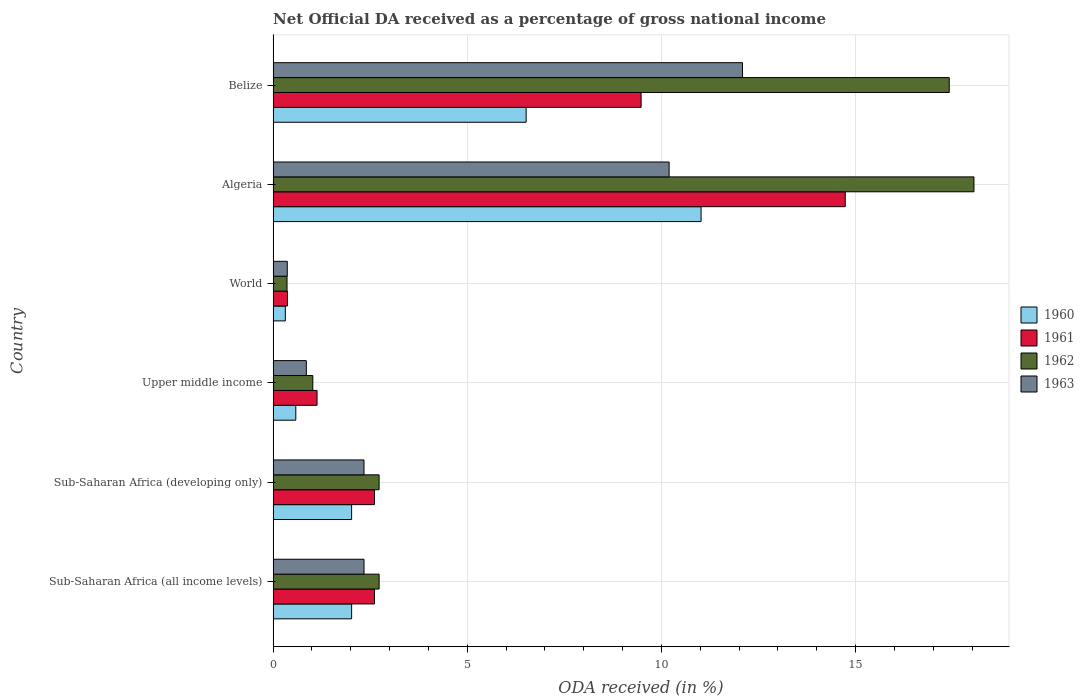How many groups of bars are there?
Keep it short and to the point. 6. Are the number of bars per tick equal to the number of legend labels?
Make the answer very short. Yes. Are the number of bars on each tick of the Y-axis equal?
Provide a short and direct response. Yes. How many bars are there on the 3rd tick from the top?
Your answer should be very brief. 4. How many bars are there on the 3rd tick from the bottom?
Offer a very short reply. 4. What is the label of the 6th group of bars from the top?
Offer a terse response. Sub-Saharan Africa (all income levels). In how many cases, is the number of bars for a given country not equal to the number of legend labels?
Give a very brief answer. 0. What is the net official DA received in 1962 in Sub-Saharan Africa (developing only)?
Offer a terse response. 2.73. Across all countries, what is the maximum net official DA received in 1961?
Offer a terse response. 14.73. Across all countries, what is the minimum net official DA received in 1961?
Give a very brief answer. 0.37. In which country was the net official DA received in 1962 maximum?
Ensure brevity in your answer.  Algeria. In which country was the net official DA received in 1963 minimum?
Your response must be concise. World. What is the total net official DA received in 1961 in the graph?
Provide a short and direct response. 30.93. What is the difference between the net official DA received in 1962 in Sub-Saharan Africa (all income levels) and that in World?
Offer a very short reply. 2.37. What is the difference between the net official DA received in 1962 in World and the net official DA received in 1960 in Belize?
Your answer should be compact. -6.16. What is the average net official DA received in 1963 per country?
Offer a terse response. 4.7. What is the difference between the net official DA received in 1963 and net official DA received in 1960 in World?
Your response must be concise. 0.05. What is the ratio of the net official DA received in 1961 in Belize to that in Sub-Saharan Africa (developing only)?
Your answer should be very brief. 3.63. What is the difference between the highest and the second highest net official DA received in 1963?
Your response must be concise. 1.89. What is the difference between the highest and the lowest net official DA received in 1960?
Ensure brevity in your answer.  10.71. In how many countries, is the net official DA received in 1961 greater than the average net official DA received in 1961 taken over all countries?
Provide a short and direct response. 2. What does the 2nd bar from the bottom in World represents?
Offer a terse response. 1961. Are all the bars in the graph horizontal?
Your response must be concise. Yes. How many countries are there in the graph?
Provide a short and direct response. 6. Are the values on the major ticks of X-axis written in scientific E-notation?
Give a very brief answer. No. Does the graph contain any zero values?
Ensure brevity in your answer.  No. Does the graph contain grids?
Offer a terse response. Yes. Where does the legend appear in the graph?
Your answer should be very brief. Center right. How many legend labels are there?
Your answer should be compact. 4. How are the legend labels stacked?
Your answer should be compact. Vertical. What is the title of the graph?
Keep it short and to the point. Net Official DA received as a percentage of gross national income. Does "1978" appear as one of the legend labels in the graph?
Your answer should be compact. No. What is the label or title of the X-axis?
Your answer should be compact. ODA received (in %). What is the ODA received (in %) of 1960 in Sub-Saharan Africa (all income levels)?
Your answer should be very brief. 2.02. What is the ODA received (in %) in 1961 in Sub-Saharan Africa (all income levels)?
Provide a succinct answer. 2.61. What is the ODA received (in %) in 1962 in Sub-Saharan Africa (all income levels)?
Give a very brief answer. 2.73. What is the ODA received (in %) of 1963 in Sub-Saharan Africa (all income levels)?
Offer a terse response. 2.34. What is the ODA received (in %) in 1960 in Sub-Saharan Africa (developing only)?
Provide a succinct answer. 2.02. What is the ODA received (in %) in 1961 in Sub-Saharan Africa (developing only)?
Offer a terse response. 2.61. What is the ODA received (in %) in 1962 in Sub-Saharan Africa (developing only)?
Give a very brief answer. 2.73. What is the ODA received (in %) in 1963 in Sub-Saharan Africa (developing only)?
Make the answer very short. 2.34. What is the ODA received (in %) in 1960 in Upper middle income?
Offer a terse response. 0.58. What is the ODA received (in %) of 1961 in Upper middle income?
Offer a very short reply. 1.13. What is the ODA received (in %) in 1962 in Upper middle income?
Keep it short and to the point. 1.02. What is the ODA received (in %) of 1963 in Upper middle income?
Offer a very short reply. 0.86. What is the ODA received (in %) in 1960 in World?
Provide a succinct answer. 0.31. What is the ODA received (in %) of 1961 in World?
Offer a very short reply. 0.37. What is the ODA received (in %) in 1962 in World?
Your answer should be compact. 0.36. What is the ODA received (in %) of 1963 in World?
Provide a short and direct response. 0.36. What is the ODA received (in %) in 1960 in Algeria?
Keep it short and to the point. 11.02. What is the ODA received (in %) of 1961 in Algeria?
Offer a terse response. 14.73. What is the ODA received (in %) in 1962 in Algeria?
Make the answer very short. 18.05. What is the ODA received (in %) of 1963 in Algeria?
Provide a short and direct response. 10.2. What is the ODA received (in %) of 1960 in Belize?
Make the answer very short. 6.52. What is the ODA received (in %) of 1961 in Belize?
Your answer should be very brief. 9.48. What is the ODA received (in %) in 1962 in Belize?
Provide a short and direct response. 17.41. What is the ODA received (in %) of 1963 in Belize?
Give a very brief answer. 12.09. Across all countries, what is the maximum ODA received (in %) in 1960?
Your answer should be compact. 11.02. Across all countries, what is the maximum ODA received (in %) of 1961?
Your answer should be compact. 14.73. Across all countries, what is the maximum ODA received (in %) in 1962?
Keep it short and to the point. 18.05. Across all countries, what is the maximum ODA received (in %) in 1963?
Your response must be concise. 12.09. Across all countries, what is the minimum ODA received (in %) of 1960?
Offer a terse response. 0.31. Across all countries, what is the minimum ODA received (in %) of 1961?
Provide a short and direct response. 0.37. Across all countries, what is the minimum ODA received (in %) of 1962?
Offer a very short reply. 0.36. Across all countries, what is the minimum ODA received (in %) of 1963?
Ensure brevity in your answer.  0.36. What is the total ODA received (in %) of 1960 in the graph?
Offer a very short reply. 22.48. What is the total ODA received (in %) in 1961 in the graph?
Your answer should be very brief. 30.93. What is the total ODA received (in %) in 1962 in the graph?
Ensure brevity in your answer.  42.3. What is the total ODA received (in %) in 1963 in the graph?
Keep it short and to the point. 28.19. What is the difference between the ODA received (in %) in 1960 in Sub-Saharan Africa (all income levels) and that in Sub-Saharan Africa (developing only)?
Your answer should be compact. 0. What is the difference between the ODA received (in %) of 1961 in Sub-Saharan Africa (all income levels) and that in Sub-Saharan Africa (developing only)?
Offer a terse response. 0. What is the difference between the ODA received (in %) in 1962 in Sub-Saharan Africa (all income levels) and that in Sub-Saharan Africa (developing only)?
Provide a succinct answer. 0. What is the difference between the ODA received (in %) of 1963 in Sub-Saharan Africa (all income levels) and that in Sub-Saharan Africa (developing only)?
Your response must be concise. 0. What is the difference between the ODA received (in %) in 1960 in Sub-Saharan Africa (all income levels) and that in Upper middle income?
Provide a short and direct response. 1.44. What is the difference between the ODA received (in %) in 1961 in Sub-Saharan Africa (all income levels) and that in Upper middle income?
Make the answer very short. 1.48. What is the difference between the ODA received (in %) in 1962 in Sub-Saharan Africa (all income levels) and that in Upper middle income?
Your answer should be compact. 1.71. What is the difference between the ODA received (in %) of 1963 in Sub-Saharan Africa (all income levels) and that in Upper middle income?
Provide a succinct answer. 1.49. What is the difference between the ODA received (in %) in 1960 in Sub-Saharan Africa (all income levels) and that in World?
Provide a short and direct response. 1.71. What is the difference between the ODA received (in %) in 1961 in Sub-Saharan Africa (all income levels) and that in World?
Your response must be concise. 2.24. What is the difference between the ODA received (in %) in 1962 in Sub-Saharan Africa (all income levels) and that in World?
Give a very brief answer. 2.37. What is the difference between the ODA received (in %) of 1963 in Sub-Saharan Africa (all income levels) and that in World?
Ensure brevity in your answer.  1.98. What is the difference between the ODA received (in %) of 1960 in Sub-Saharan Africa (all income levels) and that in Algeria?
Offer a very short reply. -9. What is the difference between the ODA received (in %) of 1961 in Sub-Saharan Africa (all income levels) and that in Algeria?
Your answer should be compact. -12.12. What is the difference between the ODA received (in %) of 1962 in Sub-Saharan Africa (all income levels) and that in Algeria?
Your answer should be compact. -15.32. What is the difference between the ODA received (in %) of 1963 in Sub-Saharan Africa (all income levels) and that in Algeria?
Provide a short and direct response. -7.86. What is the difference between the ODA received (in %) of 1960 in Sub-Saharan Africa (all income levels) and that in Belize?
Your response must be concise. -4.49. What is the difference between the ODA received (in %) of 1961 in Sub-Saharan Africa (all income levels) and that in Belize?
Provide a short and direct response. -6.87. What is the difference between the ODA received (in %) of 1962 in Sub-Saharan Africa (all income levels) and that in Belize?
Provide a succinct answer. -14.68. What is the difference between the ODA received (in %) of 1963 in Sub-Saharan Africa (all income levels) and that in Belize?
Offer a very short reply. -9.75. What is the difference between the ODA received (in %) in 1960 in Sub-Saharan Africa (developing only) and that in Upper middle income?
Keep it short and to the point. 1.44. What is the difference between the ODA received (in %) in 1961 in Sub-Saharan Africa (developing only) and that in Upper middle income?
Your answer should be very brief. 1.48. What is the difference between the ODA received (in %) of 1962 in Sub-Saharan Africa (developing only) and that in Upper middle income?
Offer a very short reply. 1.71. What is the difference between the ODA received (in %) in 1963 in Sub-Saharan Africa (developing only) and that in Upper middle income?
Make the answer very short. 1.49. What is the difference between the ODA received (in %) of 1960 in Sub-Saharan Africa (developing only) and that in World?
Offer a terse response. 1.71. What is the difference between the ODA received (in %) in 1961 in Sub-Saharan Africa (developing only) and that in World?
Offer a terse response. 2.24. What is the difference between the ODA received (in %) of 1962 in Sub-Saharan Africa (developing only) and that in World?
Offer a terse response. 2.37. What is the difference between the ODA received (in %) in 1963 in Sub-Saharan Africa (developing only) and that in World?
Your answer should be very brief. 1.98. What is the difference between the ODA received (in %) in 1960 in Sub-Saharan Africa (developing only) and that in Algeria?
Your answer should be compact. -9. What is the difference between the ODA received (in %) in 1961 in Sub-Saharan Africa (developing only) and that in Algeria?
Your answer should be very brief. -12.12. What is the difference between the ODA received (in %) in 1962 in Sub-Saharan Africa (developing only) and that in Algeria?
Your answer should be compact. -15.32. What is the difference between the ODA received (in %) in 1963 in Sub-Saharan Africa (developing only) and that in Algeria?
Offer a terse response. -7.86. What is the difference between the ODA received (in %) in 1960 in Sub-Saharan Africa (developing only) and that in Belize?
Your answer should be compact. -4.49. What is the difference between the ODA received (in %) of 1961 in Sub-Saharan Africa (developing only) and that in Belize?
Your answer should be very brief. -6.87. What is the difference between the ODA received (in %) of 1962 in Sub-Saharan Africa (developing only) and that in Belize?
Keep it short and to the point. -14.68. What is the difference between the ODA received (in %) of 1963 in Sub-Saharan Africa (developing only) and that in Belize?
Provide a short and direct response. -9.75. What is the difference between the ODA received (in %) in 1960 in Upper middle income and that in World?
Ensure brevity in your answer.  0.27. What is the difference between the ODA received (in %) of 1961 in Upper middle income and that in World?
Offer a very short reply. 0.76. What is the difference between the ODA received (in %) of 1962 in Upper middle income and that in World?
Ensure brevity in your answer.  0.66. What is the difference between the ODA received (in %) in 1963 in Upper middle income and that in World?
Make the answer very short. 0.49. What is the difference between the ODA received (in %) of 1960 in Upper middle income and that in Algeria?
Your answer should be very brief. -10.44. What is the difference between the ODA received (in %) of 1961 in Upper middle income and that in Algeria?
Your response must be concise. -13.6. What is the difference between the ODA received (in %) in 1962 in Upper middle income and that in Algeria?
Offer a very short reply. -17.03. What is the difference between the ODA received (in %) in 1963 in Upper middle income and that in Algeria?
Your answer should be compact. -9.34. What is the difference between the ODA received (in %) of 1960 in Upper middle income and that in Belize?
Your response must be concise. -5.93. What is the difference between the ODA received (in %) of 1961 in Upper middle income and that in Belize?
Offer a very short reply. -8.35. What is the difference between the ODA received (in %) in 1962 in Upper middle income and that in Belize?
Your answer should be compact. -16.39. What is the difference between the ODA received (in %) of 1963 in Upper middle income and that in Belize?
Offer a very short reply. -11.23. What is the difference between the ODA received (in %) in 1960 in World and that in Algeria?
Offer a very short reply. -10.71. What is the difference between the ODA received (in %) of 1961 in World and that in Algeria?
Provide a short and direct response. -14.36. What is the difference between the ODA received (in %) in 1962 in World and that in Algeria?
Provide a succinct answer. -17.69. What is the difference between the ODA received (in %) in 1963 in World and that in Algeria?
Your answer should be compact. -9.83. What is the difference between the ODA received (in %) of 1960 in World and that in Belize?
Your answer should be very brief. -6.2. What is the difference between the ODA received (in %) of 1961 in World and that in Belize?
Give a very brief answer. -9.11. What is the difference between the ODA received (in %) in 1962 in World and that in Belize?
Keep it short and to the point. -17.05. What is the difference between the ODA received (in %) of 1963 in World and that in Belize?
Your answer should be very brief. -11.72. What is the difference between the ODA received (in %) in 1960 in Algeria and that in Belize?
Provide a short and direct response. 4.51. What is the difference between the ODA received (in %) in 1961 in Algeria and that in Belize?
Provide a short and direct response. 5.26. What is the difference between the ODA received (in %) in 1962 in Algeria and that in Belize?
Your answer should be compact. 0.64. What is the difference between the ODA received (in %) of 1963 in Algeria and that in Belize?
Your answer should be compact. -1.89. What is the difference between the ODA received (in %) in 1960 in Sub-Saharan Africa (all income levels) and the ODA received (in %) in 1961 in Sub-Saharan Africa (developing only)?
Offer a terse response. -0.59. What is the difference between the ODA received (in %) in 1960 in Sub-Saharan Africa (all income levels) and the ODA received (in %) in 1962 in Sub-Saharan Africa (developing only)?
Your answer should be very brief. -0.71. What is the difference between the ODA received (in %) of 1960 in Sub-Saharan Africa (all income levels) and the ODA received (in %) of 1963 in Sub-Saharan Africa (developing only)?
Keep it short and to the point. -0.32. What is the difference between the ODA received (in %) of 1961 in Sub-Saharan Africa (all income levels) and the ODA received (in %) of 1962 in Sub-Saharan Africa (developing only)?
Your response must be concise. -0.12. What is the difference between the ODA received (in %) in 1961 in Sub-Saharan Africa (all income levels) and the ODA received (in %) in 1963 in Sub-Saharan Africa (developing only)?
Offer a terse response. 0.27. What is the difference between the ODA received (in %) of 1962 in Sub-Saharan Africa (all income levels) and the ODA received (in %) of 1963 in Sub-Saharan Africa (developing only)?
Your answer should be compact. 0.39. What is the difference between the ODA received (in %) in 1960 in Sub-Saharan Africa (all income levels) and the ODA received (in %) in 1961 in Upper middle income?
Give a very brief answer. 0.89. What is the difference between the ODA received (in %) in 1960 in Sub-Saharan Africa (all income levels) and the ODA received (in %) in 1963 in Upper middle income?
Your answer should be compact. 1.17. What is the difference between the ODA received (in %) in 1961 in Sub-Saharan Africa (all income levels) and the ODA received (in %) in 1962 in Upper middle income?
Make the answer very short. 1.59. What is the difference between the ODA received (in %) of 1961 in Sub-Saharan Africa (all income levels) and the ODA received (in %) of 1963 in Upper middle income?
Make the answer very short. 1.76. What is the difference between the ODA received (in %) in 1962 in Sub-Saharan Africa (all income levels) and the ODA received (in %) in 1963 in Upper middle income?
Keep it short and to the point. 1.87. What is the difference between the ODA received (in %) of 1960 in Sub-Saharan Africa (all income levels) and the ODA received (in %) of 1961 in World?
Provide a succinct answer. 1.65. What is the difference between the ODA received (in %) of 1960 in Sub-Saharan Africa (all income levels) and the ODA received (in %) of 1962 in World?
Offer a terse response. 1.66. What is the difference between the ODA received (in %) of 1960 in Sub-Saharan Africa (all income levels) and the ODA received (in %) of 1963 in World?
Provide a succinct answer. 1.66. What is the difference between the ODA received (in %) of 1961 in Sub-Saharan Africa (all income levels) and the ODA received (in %) of 1962 in World?
Give a very brief answer. 2.25. What is the difference between the ODA received (in %) in 1961 in Sub-Saharan Africa (all income levels) and the ODA received (in %) in 1963 in World?
Offer a terse response. 2.25. What is the difference between the ODA received (in %) in 1962 in Sub-Saharan Africa (all income levels) and the ODA received (in %) in 1963 in World?
Your answer should be compact. 2.37. What is the difference between the ODA received (in %) in 1960 in Sub-Saharan Africa (all income levels) and the ODA received (in %) in 1961 in Algeria?
Provide a short and direct response. -12.71. What is the difference between the ODA received (in %) in 1960 in Sub-Saharan Africa (all income levels) and the ODA received (in %) in 1962 in Algeria?
Ensure brevity in your answer.  -16.03. What is the difference between the ODA received (in %) of 1960 in Sub-Saharan Africa (all income levels) and the ODA received (in %) of 1963 in Algeria?
Keep it short and to the point. -8.18. What is the difference between the ODA received (in %) of 1961 in Sub-Saharan Africa (all income levels) and the ODA received (in %) of 1962 in Algeria?
Your response must be concise. -15.44. What is the difference between the ODA received (in %) in 1961 in Sub-Saharan Africa (all income levels) and the ODA received (in %) in 1963 in Algeria?
Offer a very short reply. -7.59. What is the difference between the ODA received (in %) of 1962 in Sub-Saharan Africa (all income levels) and the ODA received (in %) of 1963 in Algeria?
Offer a very short reply. -7.47. What is the difference between the ODA received (in %) of 1960 in Sub-Saharan Africa (all income levels) and the ODA received (in %) of 1961 in Belize?
Provide a short and direct response. -7.46. What is the difference between the ODA received (in %) in 1960 in Sub-Saharan Africa (all income levels) and the ODA received (in %) in 1962 in Belize?
Offer a terse response. -15.39. What is the difference between the ODA received (in %) in 1960 in Sub-Saharan Africa (all income levels) and the ODA received (in %) in 1963 in Belize?
Ensure brevity in your answer.  -10.07. What is the difference between the ODA received (in %) in 1961 in Sub-Saharan Africa (all income levels) and the ODA received (in %) in 1962 in Belize?
Make the answer very short. -14.8. What is the difference between the ODA received (in %) of 1961 in Sub-Saharan Africa (all income levels) and the ODA received (in %) of 1963 in Belize?
Provide a succinct answer. -9.48. What is the difference between the ODA received (in %) of 1962 in Sub-Saharan Africa (all income levels) and the ODA received (in %) of 1963 in Belize?
Provide a succinct answer. -9.36. What is the difference between the ODA received (in %) of 1960 in Sub-Saharan Africa (developing only) and the ODA received (in %) of 1961 in Upper middle income?
Your answer should be compact. 0.89. What is the difference between the ODA received (in %) in 1960 in Sub-Saharan Africa (developing only) and the ODA received (in %) in 1962 in Upper middle income?
Your answer should be compact. 1. What is the difference between the ODA received (in %) of 1960 in Sub-Saharan Africa (developing only) and the ODA received (in %) of 1963 in Upper middle income?
Offer a very short reply. 1.17. What is the difference between the ODA received (in %) in 1961 in Sub-Saharan Africa (developing only) and the ODA received (in %) in 1962 in Upper middle income?
Give a very brief answer. 1.59. What is the difference between the ODA received (in %) of 1961 in Sub-Saharan Africa (developing only) and the ODA received (in %) of 1963 in Upper middle income?
Keep it short and to the point. 1.75. What is the difference between the ODA received (in %) of 1962 in Sub-Saharan Africa (developing only) and the ODA received (in %) of 1963 in Upper middle income?
Your answer should be very brief. 1.87. What is the difference between the ODA received (in %) in 1960 in Sub-Saharan Africa (developing only) and the ODA received (in %) in 1961 in World?
Your answer should be compact. 1.65. What is the difference between the ODA received (in %) in 1960 in Sub-Saharan Africa (developing only) and the ODA received (in %) in 1962 in World?
Offer a very short reply. 1.66. What is the difference between the ODA received (in %) of 1960 in Sub-Saharan Africa (developing only) and the ODA received (in %) of 1963 in World?
Your response must be concise. 1.66. What is the difference between the ODA received (in %) of 1961 in Sub-Saharan Africa (developing only) and the ODA received (in %) of 1962 in World?
Offer a very short reply. 2.25. What is the difference between the ODA received (in %) of 1961 in Sub-Saharan Africa (developing only) and the ODA received (in %) of 1963 in World?
Give a very brief answer. 2.25. What is the difference between the ODA received (in %) of 1962 in Sub-Saharan Africa (developing only) and the ODA received (in %) of 1963 in World?
Your response must be concise. 2.36. What is the difference between the ODA received (in %) in 1960 in Sub-Saharan Africa (developing only) and the ODA received (in %) in 1961 in Algeria?
Ensure brevity in your answer.  -12.71. What is the difference between the ODA received (in %) of 1960 in Sub-Saharan Africa (developing only) and the ODA received (in %) of 1962 in Algeria?
Your answer should be very brief. -16.03. What is the difference between the ODA received (in %) of 1960 in Sub-Saharan Africa (developing only) and the ODA received (in %) of 1963 in Algeria?
Make the answer very short. -8.18. What is the difference between the ODA received (in %) in 1961 in Sub-Saharan Africa (developing only) and the ODA received (in %) in 1962 in Algeria?
Keep it short and to the point. -15.44. What is the difference between the ODA received (in %) in 1961 in Sub-Saharan Africa (developing only) and the ODA received (in %) in 1963 in Algeria?
Provide a succinct answer. -7.59. What is the difference between the ODA received (in %) of 1962 in Sub-Saharan Africa (developing only) and the ODA received (in %) of 1963 in Algeria?
Keep it short and to the point. -7.47. What is the difference between the ODA received (in %) of 1960 in Sub-Saharan Africa (developing only) and the ODA received (in %) of 1961 in Belize?
Make the answer very short. -7.46. What is the difference between the ODA received (in %) in 1960 in Sub-Saharan Africa (developing only) and the ODA received (in %) in 1962 in Belize?
Your answer should be very brief. -15.39. What is the difference between the ODA received (in %) in 1960 in Sub-Saharan Africa (developing only) and the ODA received (in %) in 1963 in Belize?
Provide a succinct answer. -10.07. What is the difference between the ODA received (in %) in 1961 in Sub-Saharan Africa (developing only) and the ODA received (in %) in 1962 in Belize?
Keep it short and to the point. -14.8. What is the difference between the ODA received (in %) of 1961 in Sub-Saharan Africa (developing only) and the ODA received (in %) of 1963 in Belize?
Provide a short and direct response. -9.48. What is the difference between the ODA received (in %) in 1962 in Sub-Saharan Africa (developing only) and the ODA received (in %) in 1963 in Belize?
Offer a very short reply. -9.36. What is the difference between the ODA received (in %) of 1960 in Upper middle income and the ODA received (in %) of 1961 in World?
Offer a very short reply. 0.21. What is the difference between the ODA received (in %) of 1960 in Upper middle income and the ODA received (in %) of 1962 in World?
Your response must be concise. 0.23. What is the difference between the ODA received (in %) of 1960 in Upper middle income and the ODA received (in %) of 1963 in World?
Offer a terse response. 0.22. What is the difference between the ODA received (in %) in 1961 in Upper middle income and the ODA received (in %) in 1962 in World?
Provide a short and direct response. 0.77. What is the difference between the ODA received (in %) in 1961 in Upper middle income and the ODA received (in %) in 1963 in World?
Your answer should be compact. 0.77. What is the difference between the ODA received (in %) in 1962 in Upper middle income and the ODA received (in %) in 1963 in World?
Provide a short and direct response. 0.66. What is the difference between the ODA received (in %) of 1960 in Upper middle income and the ODA received (in %) of 1961 in Algeria?
Provide a succinct answer. -14.15. What is the difference between the ODA received (in %) in 1960 in Upper middle income and the ODA received (in %) in 1962 in Algeria?
Ensure brevity in your answer.  -17.46. What is the difference between the ODA received (in %) in 1960 in Upper middle income and the ODA received (in %) in 1963 in Algeria?
Provide a short and direct response. -9.61. What is the difference between the ODA received (in %) in 1961 in Upper middle income and the ODA received (in %) in 1962 in Algeria?
Your response must be concise. -16.92. What is the difference between the ODA received (in %) of 1961 in Upper middle income and the ODA received (in %) of 1963 in Algeria?
Give a very brief answer. -9.07. What is the difference between the ODA received (in %) of 1962 in Upper middle income and the ODA received (in %) of 1963 in Algeria?
Your answer should be very brief. -9.18. What is the difference between the ODA received (in %) in 1960 in Upper middle income and the ODA received (in %) in 1961 in Belize?
Your answer should be compact. -8.89. What is the difference between the ODA received (in %) in 1960 in Upper middle income and the ODA received (in %) in 1962 in Belize?
Provide a short and direct response. -16.83. What is the difference between the ODA received (in %) in 1960 in Upper middle income and the ODA received (in %) in 1963 in Belize?
Ensure brevity in your answer.  -11.5. What is the difference between the ODA received (in %) in 1961 in Upper middle income and the ODA received (in %) in 1962 in Belize?
Ensure brevity in your answer.  -16.28. What is the difference between the ODA received (in %) of 1961 in Upper middle income and the ODA received (in %) of 1963 in Belize?
Your answer should be very brief. -10.96. What is the difference between the ODA received (in %) of 1962 in Upper middle income and the ODA received (in %) of 1963 in Belize?
Ensure brevity in your answer.  -11.07. What is the difference between the ODA received (in %) in 1960 in World and the ODA received (in %) in 1961 in Algeria?
Keep it short and to the point. -14.42. What is the difference between the ODA received (in %) of 1960 in World and the ODA received (in %) of 1962 in Algeria?
Ensure brevity in your answer.  -17.73. What is the difference between the ODA received (in %) in 1960 in World and the ODA received (in %) in 1963 in Algeria?
Provide a succinct answer. -9.88. What is the difference between the ODA received (in %) of 1961 in World and the ODA received (in %) of 1962 in Algeria?
Your answer should be very brief. -17.68. What is the difference between the ODA received (in %) in 1961 in World and the ODA received (in %) in 1963 in Algeria?
Provide a short and direct response. -9.83. What is the difference between the ODA received (in %) of 1962 in World and the ODA received (in %) of 1963 in Algeria?
Your response must be concise. -9.84. What is the difference between the ODA received (in %) of 1960 in World and the ODA received (in %) of 1961 in Belize?
Offer a very short reply. -9.16. What is the difference between the ODA received (in %) of 1960 in World and the ODA received (in %) of 1962 in Belize?
Provide a short and direct response. -17.1. What is the difference between the ODA received (in %) of 1960 in World and the ODA received (in %) of 1963 in Belize?
Offer a terse response. -11.77. What is the difference between the ODA received (in %) in 1961 in World and the ODA received (in %) in 1962 in Belize?
Ensure brevity in your answer.  -17.04. What is the difference between the ODA received (in %) of 1961 in World and the ODA received (in %) of 1963 in Belize?
Keep it short and to the point. -11.72. What is the difference between the ODA received (in %) of 1962 in World and the ODA received (in %) of 1963 in Belize?
Ensure brevity in your answer.  -11.73. What is the difference between the ODA received (in %) of 1960 in Algeria and the ODA received (in %) of 1961 in Belize?
Your response must be concise. 1.54. What is the difference between the ODA received (in %) of 1960 in Algeria and the ODA received (in %) of 1962 in Belize?
Ensure brevity in your answer.  -6.39. What is the difference between the ODA received (in %) in 1960 in Algeria and the ODA received (in %) in 1963 in Belize?
Offer a terse response. -1.07. What is the difference between the ODA received (in %) of 1961 in Algeria and the ODA received (in %) of 1962 in Belize?
Your answer should be compact. -2.68. What is the difference between the ODA received (in %) of 1961 in Algeria and the ODA received (in %) of 1963 in Belize?
Provide a succinct answer. 2.65. What is the difference between the ODA received (in %) of 1962 in Algeria and the ODA received (in %) of 1963 in Belize?
Your answer should be compact. 5.96. What is the average ODA received (in %) in 1960 per country?
Give a very brief answer. 3.75. What is the average ODA received (in %) in 1961 per country?
Ensure brevity in your answer.  5.16. What is the average ODA received (in %) of 1962 per country?
Provide a succinct answer. 7.05. What is the average ODA received (in %) of 1963 per country?
Your answer should be very brief. 4.7. What is the difference between the ODA received (in %) in 1960 and ODA received (in %) in 1961 in Sub-Saharan Africa (all income levels)?
Offer a very short reply. -0.59. What is the difference between the ODA received (in %) in 1960 and ODA received (in %) in 1962 in Sub-Saharan Africa (all income levels)?
Provide a short and direct response. -0.71. What is the difference between the ODA received (in %) of 1960 and ODA received (in %) of 1963 in Sub-Saharan Africa (all income levels)?
Offer a very short reply. -0.32. What is the difference between the ODA received (in %) of 1961 and ODA received (in %) of 1962 in Sub-Saharan Africa (all income levels)?
Ensure brevity in your answer.  -0.12. What is the difference between the ODA received (in %) in 1961 and ODA received (in %) in 1963 in Sub-Saharan Africa (all income levels)?
Provide a short and direct response. 0.27. What is the difference between the ODA received (in %) of 1962 and ODA received (in %) of 1963 in Sub-Saharan Africa (all income levels)?
Offer a terse response. 0.39. What is the difference between the ODA received (in %) of 1960 and ODA received (in %) of 1961 in Sub-Saharan Africa (developing only)?
Offer a terse response. -0.59. What is the difference between the ODA received (in %) in 1960 and ODA received (in %) in 1962 in Sub-Saharan Africa (developing only)?
Your answer should be compact. -0.71. What is the difference between the ODA received (in %) in 1960 and ODA received (in %) in 1963 in Sub-Saharan Africa (developing only)?
Offer a terse response. -0.32. What is the difference between the ODA received (in %) of 1961 and ODA received (in %) of 1962 in Sub-Saharan Africa (developing only)?
Offer a very short reply. -0.12. What is the difference between the ODA received (in %) in 1961 and ODA received (in %) in 1963 in Sub-Saharan Africa (developing only)?
Offer a very short reply. 0.27. What is the difference between the ODA received (in %) of 1962 and ODA received (in %) of 1963 in Sub-Saharan Africa (developing only)?
Provide a succinct answer. 0.39. What is the difference between the ODA received (in %) of 1960 and ODA received (in %) of 1961 in Upper middle income?
Offer a terse response. -0.55. What is the difference between the ODA received (in %) of 1960 and ODA received (in %) of 1962 in Upper middle income?
Provide a short and direct response. -0.44. What is the difference between the ODA received (in %) in 1960 and ODA received (in %) in 1963 in Upper middle income?
Your answer should be very brief. -0.27. What is the difference between the ODA received (in %) of 1961 and ODA received (in %) of 1962 in Upper middle income?
Give a very brief answer. 0.11. What is the difference between the ODA received (in %) of 1961 and ODA received (in %) of 1963 in Upper middle income?
Ensure brevity in your answer.  0.28. What is the difference between the ODA received (in %) of 1962 and ODA received (in %) of 1963 in Upper middle income?
Make the answer very short. 0.17. What is the difference between the ODA received (in %) of 1960 and ODA received (in %) of 1961 in World?
Make the answer very short. -0.06. What is the difference between the ODA received (in %) of 1960 and ODA received (in %) of 1962 in World?
Make the answer very short. -0.04. What is the difference between the ODA received (in %) in 1960 and ODA received (in %) in 1963 in World?
Provide a succinct answer. -0.05. What is the difference between the ODA received (in %) in 1961 and ODA received (in %) in 1962 in World?
Keep it short and to the point. 0.01. What is the difference between the ODA received (in %) of 1961 and ODA received (in %) of 1963 in World?
Offer a terse response. 0. What is the difference between the ODA received (in %) of 1962 and ODA received (in %) of 1963 in World?
Your answer should be compact. -0.01. What is the difference between the ODA received (in %) in 1960 and ODA received (in %) in 1961 in Algeria?
Provide a succinct answer. -3.71. What is the difference between the ODA received (in %) of 1960 and ODA received (in %) of 1962 in Algeria?
Ensure brevity in your answer.  -7.03. What is the difference between the ODA received (in %) of 1960 and ODA received (in %) of 1963 in Algeria?
Give a very brief answer. 0.82. What is the difference between the ODA received (in %) in 1961 and ODA received (in %) in 1962 in Algeria?
Your answer should be very brief. -3.31. What is the difference between the ODA received (in %) of 1961 and ODA received (in %) of 1963 in Algeria?
Make the answer very short. 4.54. What is the difference between the ODA received (in %) in 1962 and ODA received (in %) in 1963 in Algeria?
Offer a very short reply. 7.85. What is the difference between the ODA received (in %) in 1960 and ODA received (in %) in 1961 in Belize?
Offer a terse response. -2.96. What is the difference between the ODA received (in %) in 1960 and ODA received (in %) in 1962 in Belize?
Your response must be concise. -10.9. What is the difference between the ODA received (in %) in 1960 and ODA received (in %) in 1963 in Belize?
Ensure brevity in your answer.  -5.57. What is the difference between the ODA received (in %) in 1961 and ODA received (in %) in 1962 in Belize?
Your answer should be compact. -7.93. What is the difference between the ODA received (in %) of 1961 and ODA received (in %) of 1963 in Belize?
Keep it short and to the point. -2.61. What is the difference between the ODA received (in %) of 1962 and ODA received (in %) of 1963 in Belize?
Make the answer very short. 5.32. What is the ratio of the ODA received (in %) in 1961 in Sub-Saharan Africa (all income levels) to that in Sub-Saharan Africa (developing only)?
Provide a succinct answer. 1. What is the ratio of the ODA received (in %) in 1962 in Sub-Saharan Africa (all income levels) to that in Sub-Saharan Africa (developing only)?
Your answer should be very brief. 1. What is the ratio of the ODA received (in %) of 1960 in Sub-Saharan Africa (all income levels) to that in Upper middle income?
Offer a terse response. 3.46. What is the ratio of the ODA received (in %) in 1961 in Sub-Saharan Africa (all income levels) to that in Upper middle income?
Your answer should be compact. 2.31. What is the ratio of the ODA received (in %) of 1962 in Sub-Saharan Africa (all income levels) to that in Upper middle income?
Provide a succinct answer. 2.67. What is the ratio of the ODA received (in %) in 1963 in Sub-Saharan Africa (all income levels) to that in Upper middle income?
Ensure brevity in your answer.  2.74. What is the ratio of the ODA received (in %) of 1960 in Sub-Saharan Africa (all income levels) to that in World?
Your response must be concise. 6.43. What is the ratio of the ODA received (in %) in 1961 in Sub-Saharan Africa (all income levels) to that in World?
Provide a succinct answer. 7.07. What is the ratio of the ODA received (in %) of 1962 in Sub-Saharan Africa (all income levels) to that in World?
Offer a terse response. 7.62. What is the ratio of the ODA received (in %) of 1963 in Sub-Saharan Africa (all income levels) to that in World?
Offer a very short reply. 6.42. What is the ratio of the ODA received (in %) of 1960 in Sub-Saharan Africa (all income levels) to that in Algeria?
Your answer should be compact. 0.18. What is the ratio of the ODA received (in %) of 1961 in Sub-Saharan Africa (all income levels) to that in Algeria?
Give a very brief answer. 0.18. What is the ratio of the ODA received (in %) of 1962 in Sub-Saharan Africa (all income levels) to that in Algeria?
Your answer should be very brief. 0.15. What is the ratio of the ODA received (in %) in 1963 in Sub-Saharan Africa (all income levels) to that in Algeria?
Ensure brevity in your answer.  0.23. What is the ratio of the ODA received (in %) of 1960 in Sub-Saharan Africa (all income levels) to that in Belize?
Keep it short and to the point. 0.31. What is the ratio of the ODA received (in %) in 1961 in Sub-Saharan Africa (all income levels) to that in Belize?
Give a very brief answer. 0.28. What is the ratio of the ODA received (in %) of 1962 in Sub-Saharan Africa (all income levels) to that in Belize?
Give a very brief answer. 0.16. What is the ratio of the ODA received (in %) of 1963 in Sub-Saharan Africa (all income levels) to that in Belize?
Your response must be concise. 0.19. What is the ratio of the ODA received (in %) of 1960 in Sub-Saharan Africa (developing only) to that in Upper middle income?
Your answer should be very brief. 3.46. What is the ratio of the ODA received (in %) of 1961 in Sub-Saharan Africa (developing only) to that in Upper middle income?
Your response must be concise. 2.31. What is the ratio of the ODA received (in %) of 1962 in Sub-Saharan Africa (developing only) to that in Upper middle income?
Your answer should be very brief. 2.67. What is the ratio of the ODA received (in %) in 1963 in Sub-Saharan Africa (developing only) to that in Upper middle income?
Your response must be concise. 2.74. What is the ratio of the ODA received (in %) in 1960 in Sub-Saharan Africa (developing only) to that in World?
Your answer should be compact. 6.43. What is the ratio of the ODA received (in %) of 1961 in Sub-Saharan Africa (developing only) to that in World?
Make the answer very short. 7.06. What is the ratio of the ODA received (in %) of 1962 in Sub-Saharan Africa (developing only) to that in World?
Keep it short and to the point. 7.62. What is the ratio of the ODA received (in %) of 1963 in Sub-Saharan Africa (developing only) to that in World?
Your answer should be very brief. 6.42. What is the ratio of the ODA received (in %) of 1960 in Sub-Saharan Africa (developing only) to that in Algeria?
Provide a succinct answer. 0.18. What is the ratio of the ODA received (in %) in 1961 in Sub-Saharan Africa (developing only) to that in Algeria?
Give a very brief answer. 0.18. What is the ratio of the ODA received (in %) in 1962 in Sub-Saharan Africa (developing only) to that in Algeria?
Your answer should be very brief. 0.15. What is the ratio of the ODA received (in %) of 1963 in Sub-Saharan Africa (developing only) to that in Algeria?
Ensure brevity in your answer.  0.23. What is the ratio of the ODA received (in %) in 1960 in Sub-Saharan Africa (developing only) to that in Belize?
Your answer should be very brief. 0.31. What is the ratio of the ODA received (in %) of 1961 in Sub-Saharan Africa (developing only) to that in Belize?
Keep it short and to the point. 0.28. What is the ratio of the ODA received (in %) in 1962 in Sub-Saharan Africa (developing only) to that in Belize?
Your response must be concise. 0.16. What is the ratio of the ODA received (in %) in 1963 in Sub-Saharan Africa (developing only) to that in Belize?
Your answer should be compact. 0.19. What is the ratio of the ODA received (in %) of 1960 in Upper middle income to that in World?
Offer a very short reply. 1.86. What is the ratio of the ODA received (in %) in 1961 in Upper middle income to that in World?
Ensure brevity in your answer.  3.06. What is the ratio of the ODA received (in %) of 1962 in Upper middle income to that in World?
Provide a short and direct response. 2.85. What is the ratio of the ODA received (in %) of 1963 in Upper middle income to that in World?
Your response must be concise. 2.34. What is the ratio of the ODA received (in %) of 1960 in Upper middle income to that in Algeria?
Provide a succinct answer. 0.05. What is the ratio of the ODA received (in %) in 1961 in Upper middle income to that in Algeria?
Make the answer very short. 0.08. What is the ratio of the ODA received (in %) of 1962 in Upper middle income to that in Algeria?
Offer a very short reply. 0.06. What is the ratio of the ODA received (in %) in 1963 in Upper middle income to that in Algeria?
Your answer should be very brief. 0.08. What is the ratio of the ODA received (in %) in 1960 in Upper middle income to that in Belize?
Provide a short and direct response. 0.09. What is the ratio of the ODA received (in %) of 1961 in Upper middle income to that in Belize?
Ensure brevity in your answer.  0.12. What is the ratio of the ODA received (in %) of 1962 in Upper middle income to that in Belize?
Your answer should be very brief. 0.06. What is the ratio of the ODA received (in %) of 1963 in Upper middle income to that in Belize?
Provide a succinct answer. 0.07. What is the ratio of the ODA received (in %) in 1960 in World to that in Algeria?
Provide a short and direct response. 0.03. What is the ratio of the ODA received (in %) of 1961 in World to that in Algeria?
Provide a succinct answer. 0.03. What is the ratio of the ODA received (in %) of 1962 in World to that in Algeria?
Keep it short and to the point. 0.02. What is the ratio of the ODA received (in %) of 1963 in World to that in Algeria?
Ensure brevity in your answer.  0.04. What is the ratio of the ODA received (in %) in 1960 in World to that in Belize?
Give a very brief answer. 0.05. What is the ratio of the ODA received (in %) of 1961 in World to that in Belize?
Ensure brevity in your answer.  0.04. What is the ratio of the ODA received (in %) of 1962 in World to that in Belize?
Your answer should be very brief. 0.02. What is the ratio of the ODA received (in %) of 1963 in World to that in Belize?
Offer a very short reply. 0.03. What is the ratio of the ODA received (in %) in 1960 in Algeria to that in Belize?
Ensure brevity in your answer.  1.69. What is the ratio of the ODA received (in %) of 1961 in Algeria to that in Belize?
Your answer should be compact. 1.55. What is the ratio of the ODA received (in %) in 1962 in Algeria to that in Belize?
Your answer should be compact. 1.04. What is the ratio of the ODA received (in %) in 1963 in Algeria to that in Belize?
Your answer should be very brief. 0.84. What is the difference between the highest and the second highest ODA received (in %) in 1960?
Provide a short and direct response. 4.51. What is the difference between the highest and the second highest ODA received (in %) in 1961?
Provide a succinct answer. 5.26. What is the difference between the highest and the second highest ODA received (in %) of 1962?
Your answer should be compact. 0.64. What is the difference between the highest and the second highest ODA received (in %) in 1963?
Keep it short and to the point. 1.89. What is the difference between the highest and the lowest ODA received (in %) of 1960?
Ensure brevity in your answer.  10.71. What is the difference between the highest and the lowest ODA received (in %) of 1961?
Your answer should be very brief. 14.36. What is the difference between the highest and the lowest ODA received (in %) in 1962?
Give a very brief answer. 17.69. What is the difference between the highest and the lowest ODA received (in %) of 1963?
Provide a short and direct response. 11.72. 